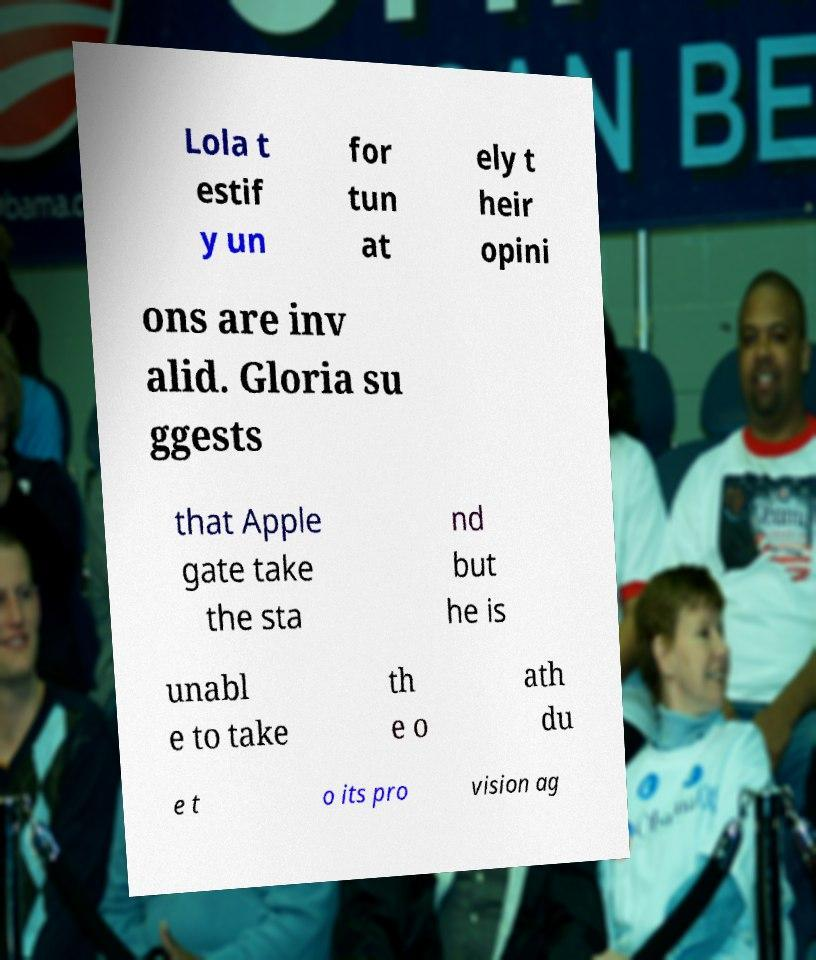Can you accurately transcribe the text from the provided image for me? Lola t estif y un for tun at ely t heir opini ons are inv alid. Gloria su ggests that Apple gate take the sta nd but he is unabl e to take th e o ath du e t o its pro vision ag 